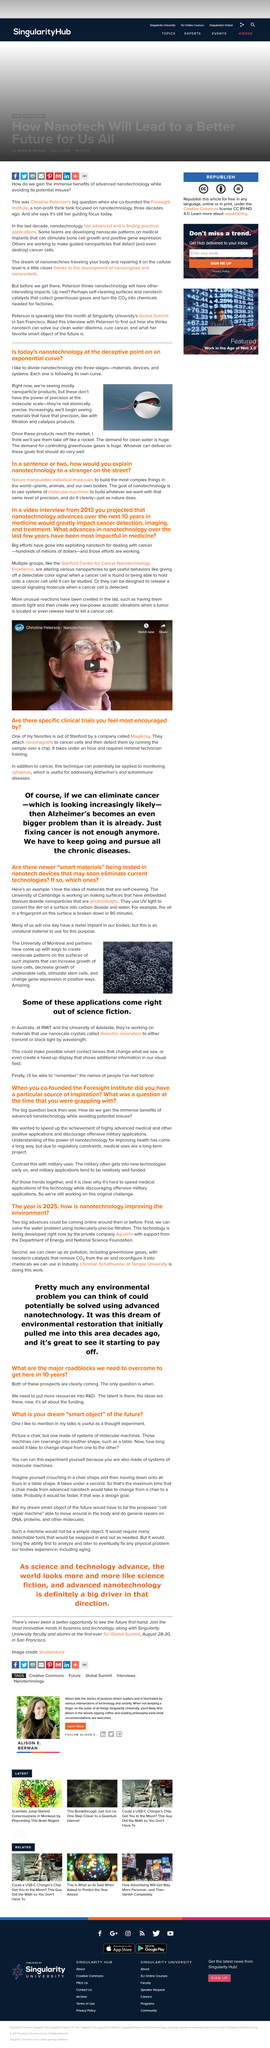List a handful of essential elements in this visual. Our research found that when titanium dioxide nanoparticles were embedded in a surface, they were able to break down oil within 90 minutes. The University of Montreal is working on developing metal implants that are more natural in the body. Nanotechnology is a cutting-edge field of microscopic technology that involves the manipulation of matter at the nanoscale, enabling significant improvements in various industries, including healthcare, energy, and electronics. There are three stages of nanotechnology, which are materials, devices, and systems. According to the article, the military enjoys two significant benefits when it comes to new technologies: early access to the latest innovations and ample funding to support the development and implementation of these technologies. 